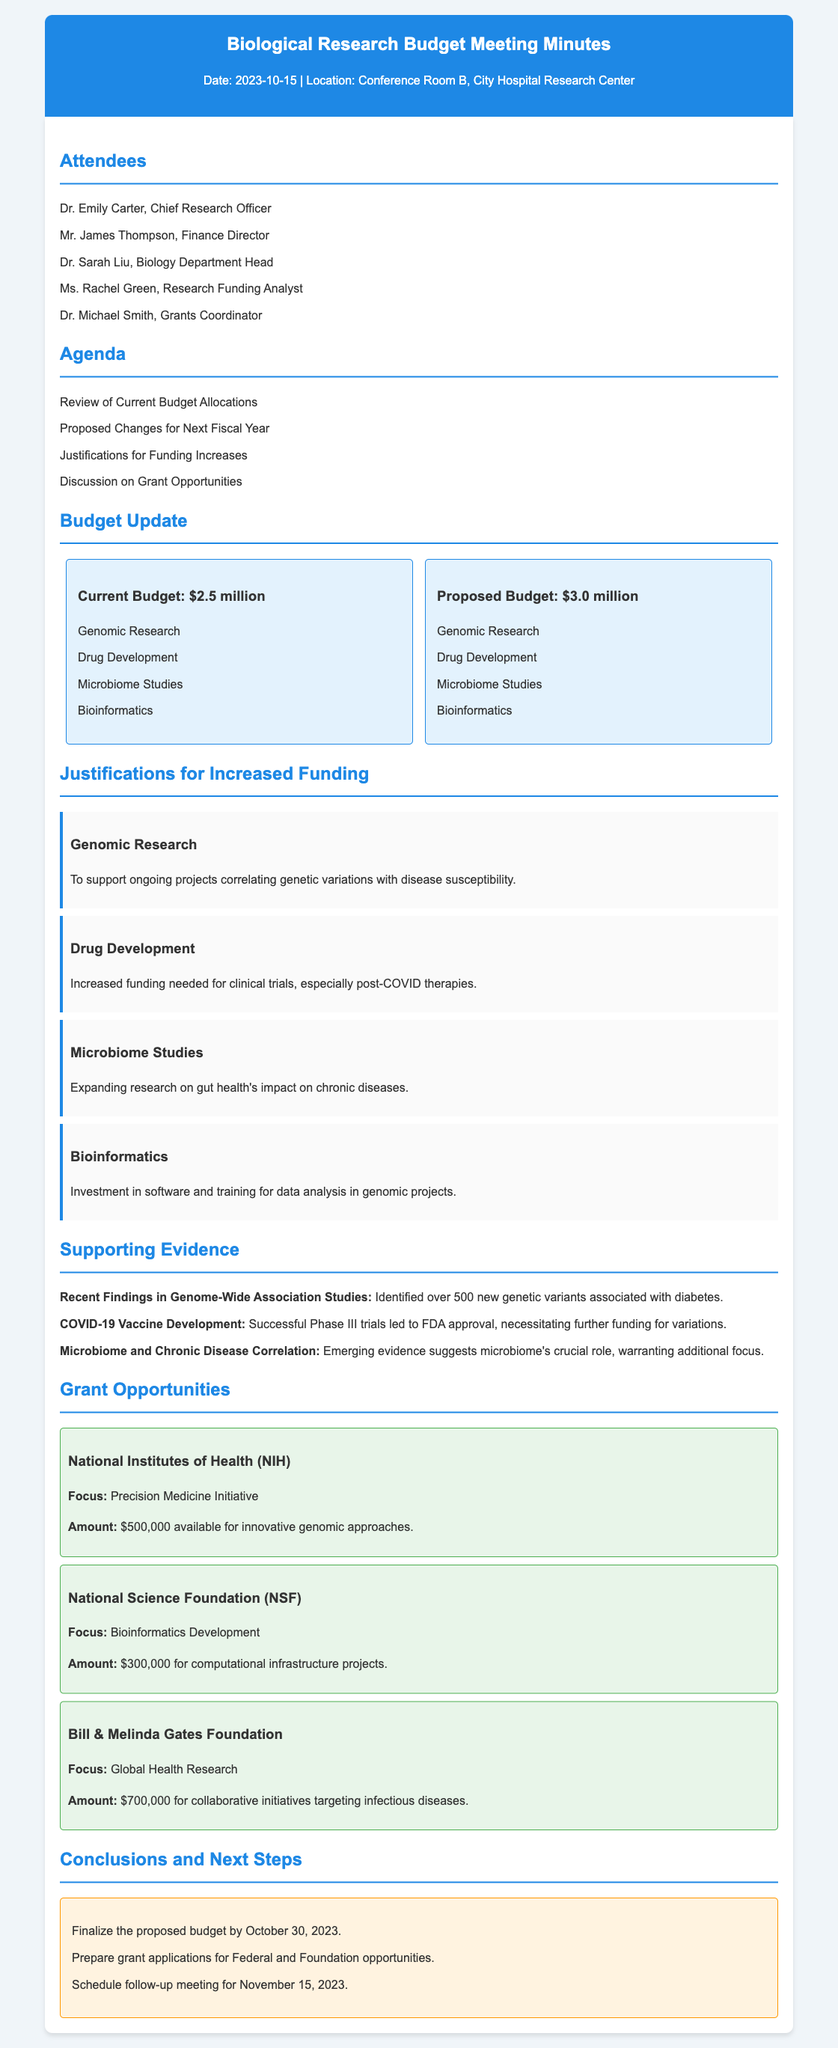What is the current budget allocation? The current budget allocation is stated directly in the document as part of the budget update section.
Answer: $2.5 million What amount is proposed for the next fiscal year's budget? This can be found in the budget update section where the proposed budget is mentioned.
Answer: $3.0 million Which research area is associated with clinical trials? The justification section lists various research areas; the specific area related to clinical trials is identified here.
Answer: Drug Development What is the focus of the NIH grant opportunity? The document specifies the focus area for each grant opportunity, including NIH.
Answer: Precision Medicine Initiative How many attendees were present at the meeting? The list of attendees in the document can help determine the total number present.
Answer: 5 What are the scheduled next steps discussed in the meeting? The document mentions the next steps in a specific section dedicated to that topic.
Answer: Finalize the proposed budget by October 30, 2023 Which chronic conditions are being examined in the microbiome studies? The justification section highlights the connection between microbiome research and certain health issues.
Answer: Chronic diseases What is the total funding available from the Bill & Melinda Gates Foundation? The specific funding amount is mentioned for that grant opportunity in the document.
Answer: $700,000 What is the date of the follow-up meeting? The next steps section directly specifies the date for the follow-up meeting.
Answer: November 15, 2023 